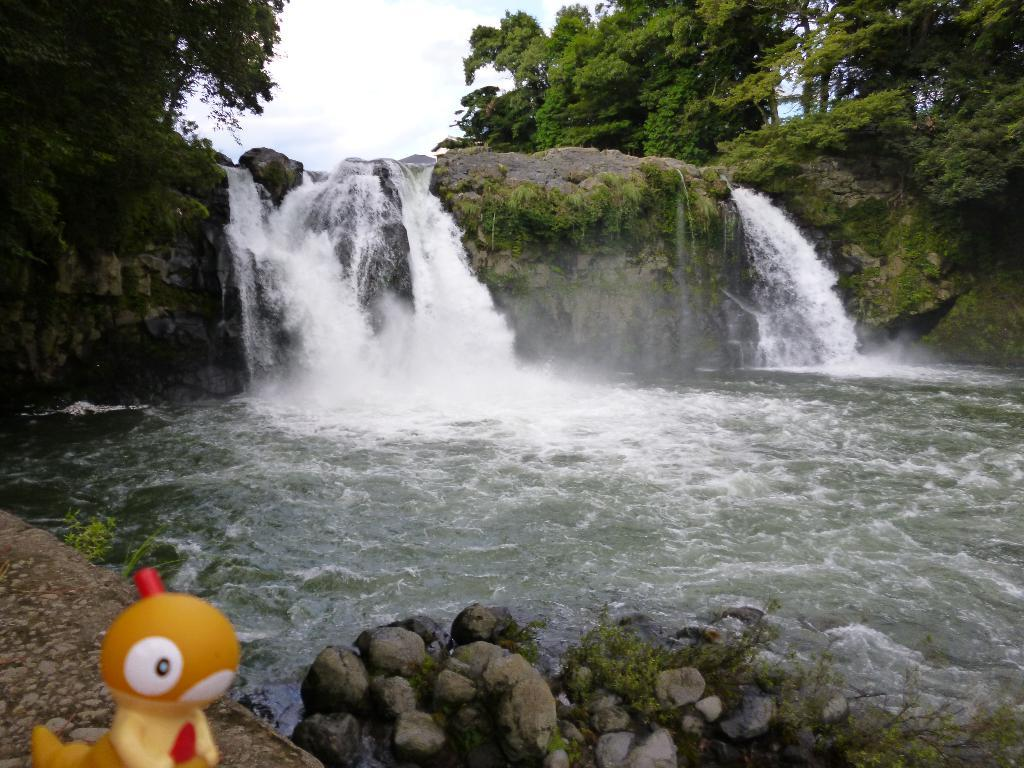What natural feature is the main subject of the image? There is a waterfall in the image. What type of vegetation is present around the waterfall? There are trees around the waterfall. What type of geological feature is visible in the image? Rocks are present in the image. What man-made object is visible in the image? There is a toy visible in the image. What reason does the train have for being in the image? There is no train present in the image, so it cannot be determined what reason it might have for being there. 